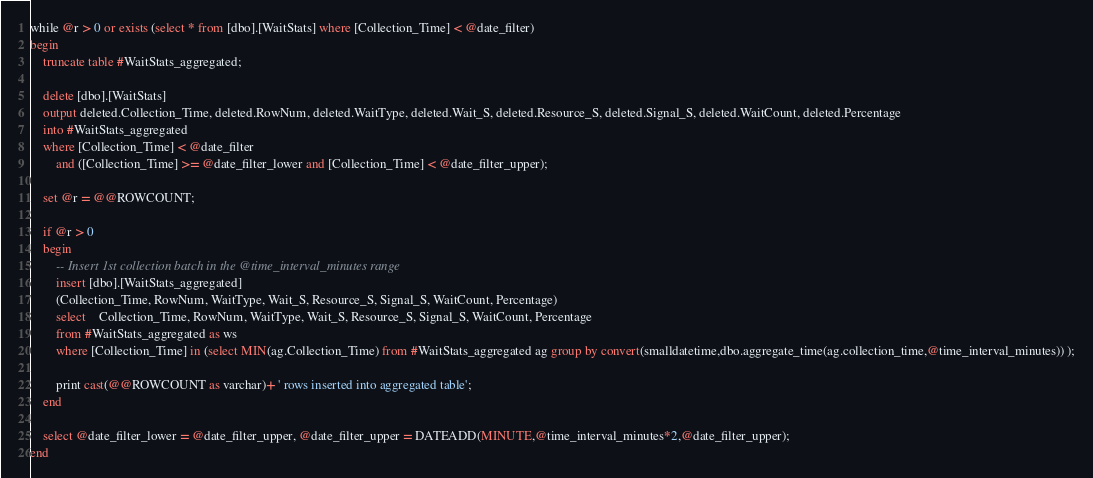<code> <loc_0><loc_0><loc_500><loc_500><_SQL_>
while @r > 0 or exists (select * from [dbo].[WaitStats] where [Collection_Time] < @date_filter)
begin
	truncate table #WaitStats_aggregated;

	delete [dbo].[WaitStats]
	output deleted.Collection_Time, deleted.RowNum, deleted.WaitType, deleted.Wait_S, deleted.Resource_S, deleted.Signal_S, deleted.WaitCount, deleted.Percentage
	into #WaitStats_aggregated
	where [Collection_Time] < @date_filter
		and ([Collection_Time] >= @date_filter_lower and [Collection_Time] < @date_filter_upper);

	set @r = @@ROWCOUNT;

	if @r > 0
	begin
		-- Insert 1st collection batch in the @time_interval_minutes range
		insert [dbo].[WaitStats_aggregated]
		(Collection_Time, RowNum, WaitType, Wait_S, Resource_S, Signal_S, WaitCount, Percentage)
		select	Collection_Time, RowNum, WaitType, Wait_S, Resource_S, Signal_S, WaitCount, Percentage
		from #WaitStats_aggregated as ws
		where [Collection_Time] in (select MIN(ag.Collection_Time) from #WaitStats_aggregated ag group by convert(smalldatetime,dbo.aggregate_time(ag.collection_time,@time_interval_minutes)) );

		print cast(@@ROWCOUNT as varchar)+ ' rows inserted into aggregated table';
	end
	
	select @date_filter_lower = @date_filter_upper, @date_filter_upper = DATEADD(MINUTE,@time_interval_minutes*2,@date_filter_upper);
end
</code> 